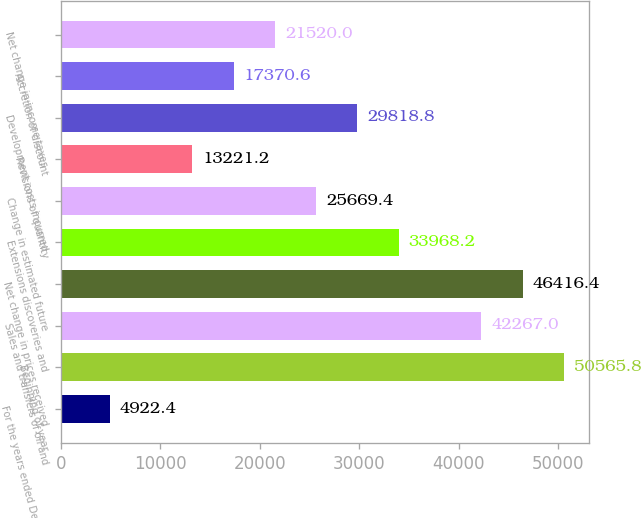Convert chart. <chart><loc_0><loc_0><loc_500><loc_500><bar_chart><fcel>For the years ended December<fcel>Beginning of year<fcel>Sales and transfers of oil and<fcel>Net change in prices received<fcel>Extensions discoveries and<fcel>Change in estimated future<fcel>Revisions of quantity<fcel>Development costs incurred<fcel>Accretion of discount<fcel>Net change in income taxes<nl><fcel>4922.4<fcel>50565.8<fcel>42267<fcel>46416.4<fcel>33968.2<fcel>25669.4<fcel>13221.2<fcel>29818.8<fcel>17370.6<fcel>21520<nl></chart> 